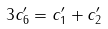Convert formula to latex. <formula><loc_0><loc_0><loc_500><loc_500>3 c _ { 6 } ^ { \prime } = c _ { 1 } ^ { \prime } + c _ { 2 } ^ { \prime }</formula> 